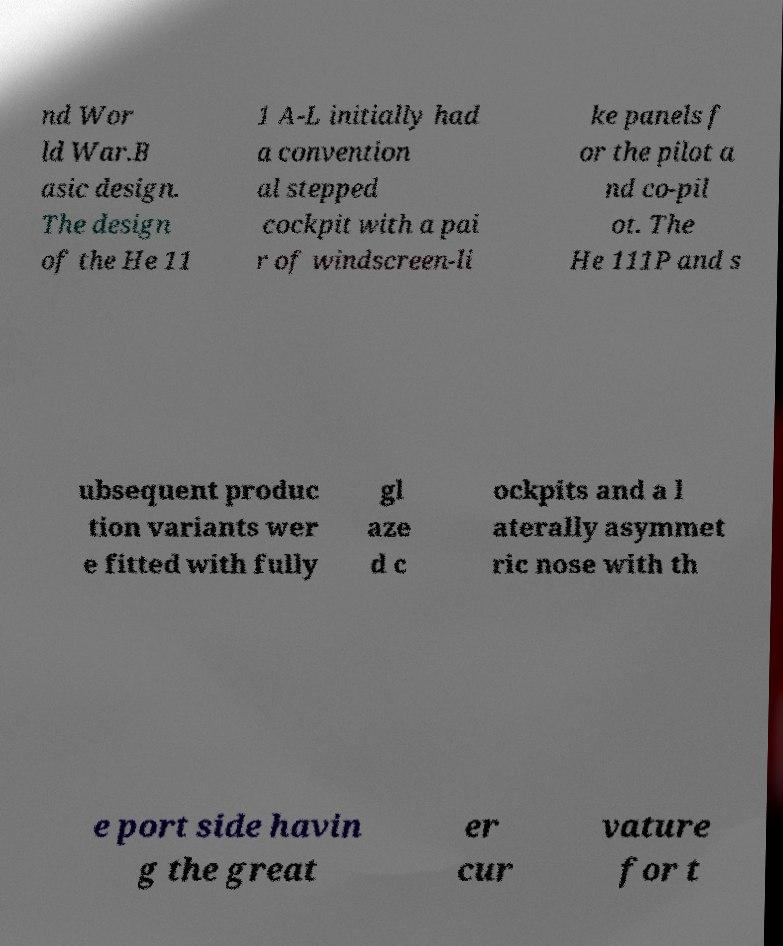Could you assist in decoding the text presented in this image and type it out clearly? nd Wor ld War.B asic design. The design of the He 11 1 A-L initially had a convention al stepped cockpit with a pai r of windscreen-li ke panels f or the pilot a nd co-pil ot. The He 111P and s ubsequent produc tion variants wer e fitted with fully gl aze d c ockpits and a l aterally asymmet ric nose with th e port side havin g the great er cur vature for t 